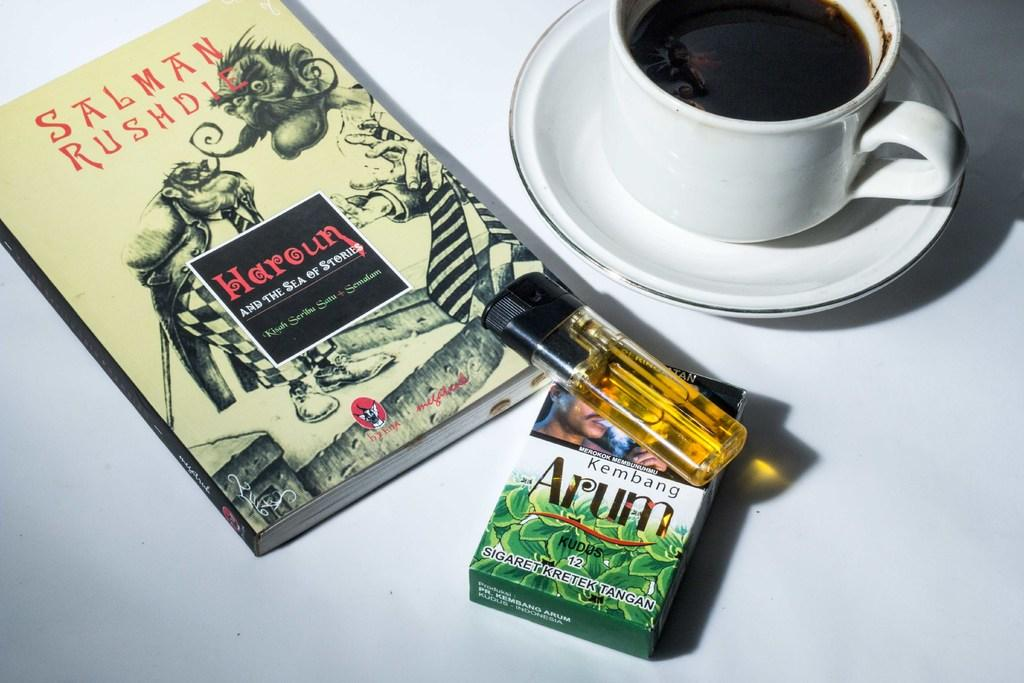<image>
Describe the image concisely. Haroun and the sea of stories was written by Salman Rushdie. 